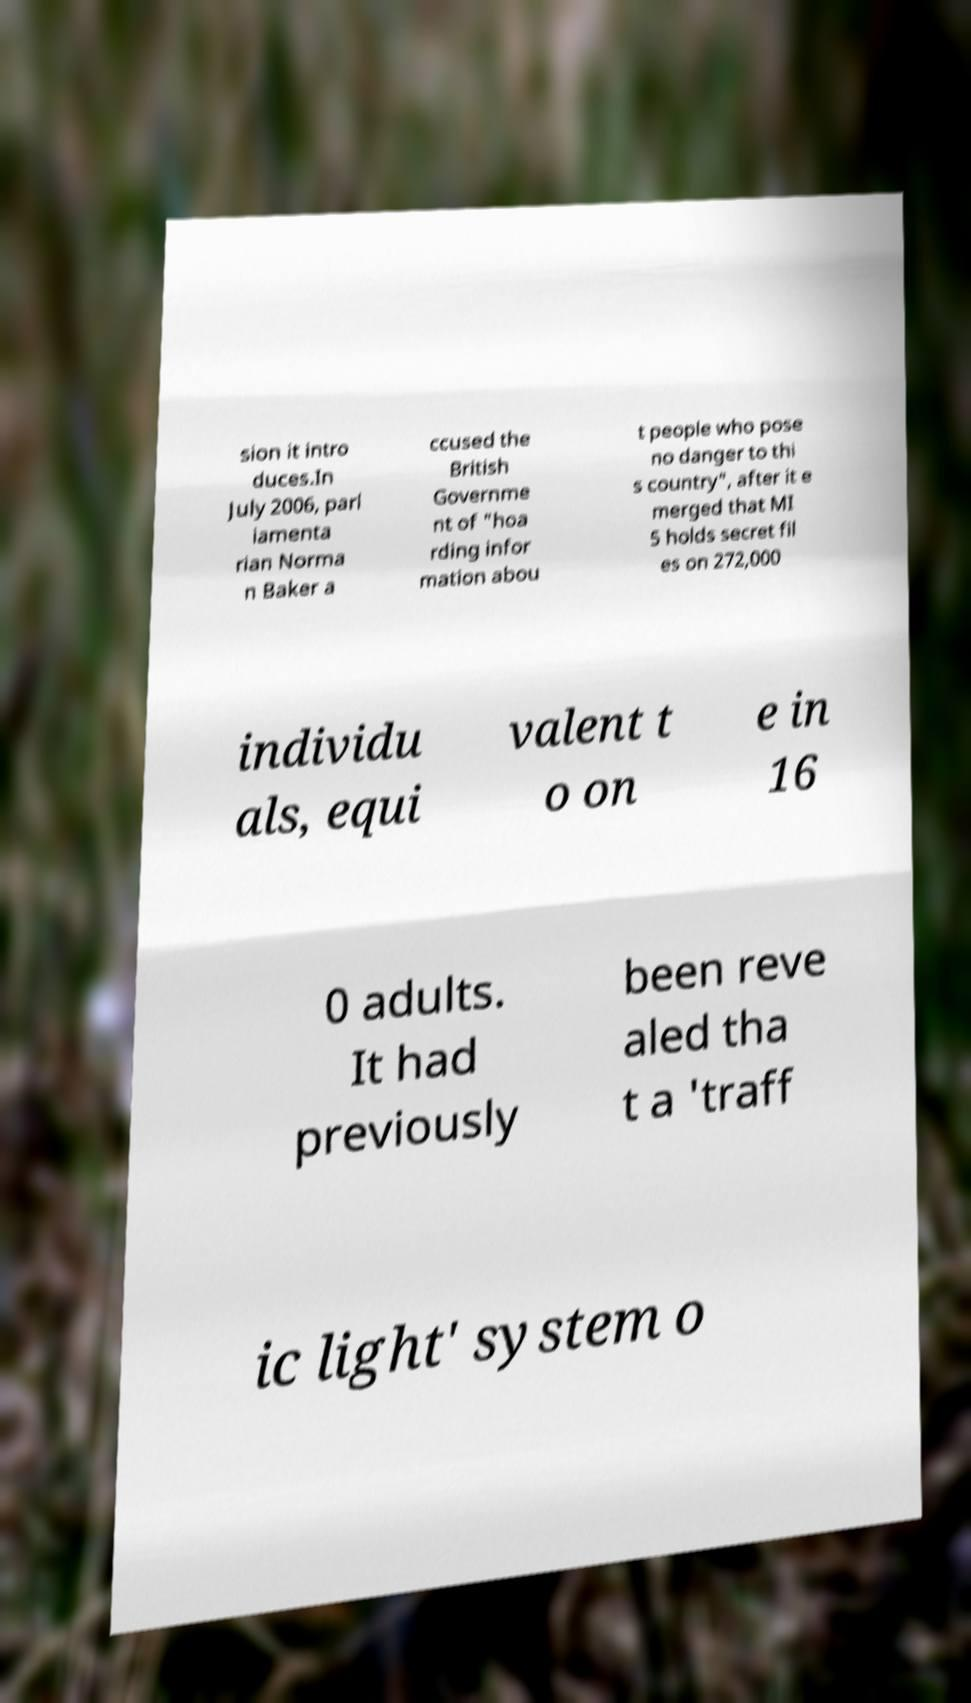I need the written content from this picture converted into text. Can you do that? sion it intro duces.In July 2006, parl iamenta rian Norma n Baker a ccused the British Governme nt of "hoa rding infor mation abou t people who pose no danger to thi s country", after it e merged that MI 5 holds secret fil es on 272,000 individu als, equi valent t o on e in 16 0 adults. It had previously been reve aled tha t a 'traff ic light' system o 